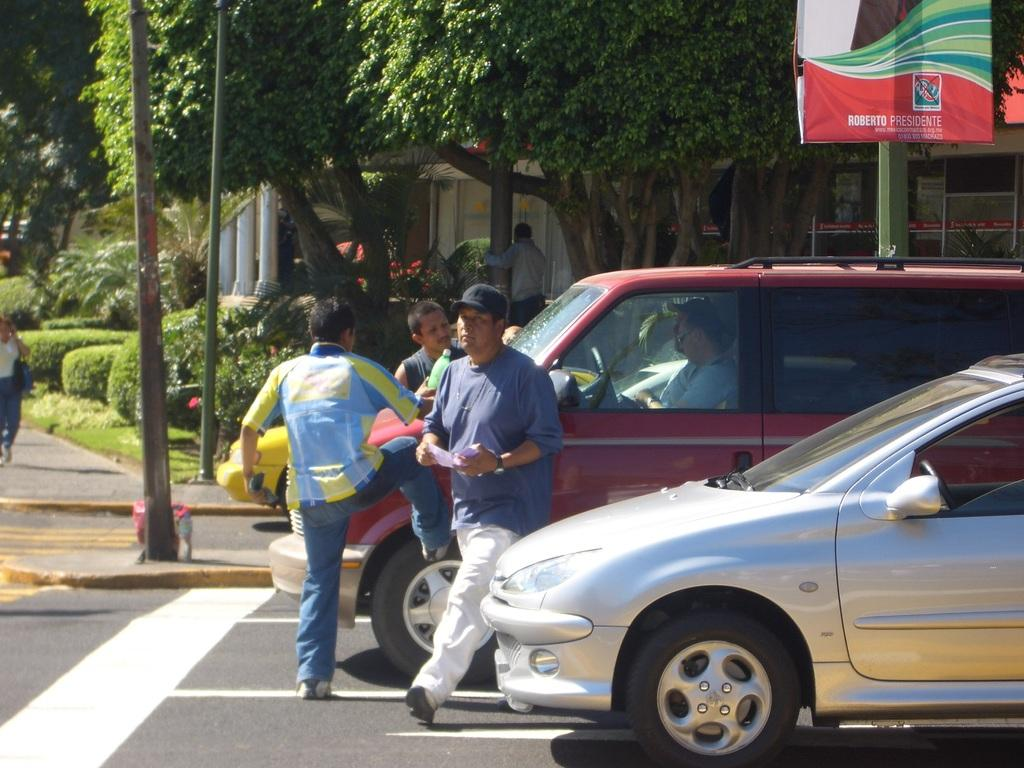How many people are in the image? There is a group of persons standing in the image. What else can be seen in the image besides the group of persons? There are two vehicles in the image. What can be seen in the background of the image? There are trees and buildings in the background of the image. What type of plantation can be seen in the image? There is no plantation present in the image. Can you describe the cast of characters in the image? The image does not depict a cast of characters; it shows a group of persons standing together. 